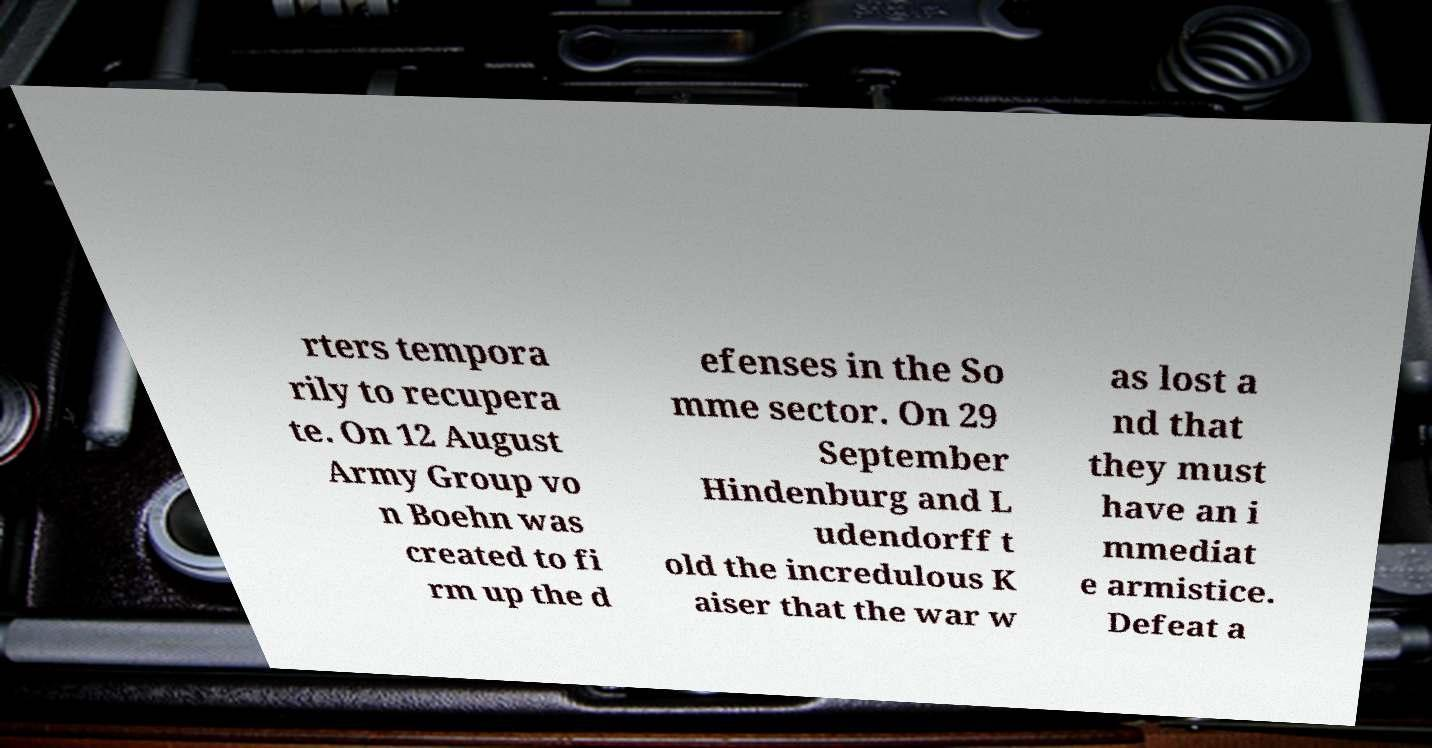Please read and relay the text visible in this image. What does it say? rters tempora rily to recupera te. On 12 August Army Group vo n Boehn was created to fi rm up the d efenses in the So mme sector. On 29 September Hindenburg and L udendorff t old the incredulous K aiser that the war w as lost a nd that they must have an i mmediat e armistice. Defeat a 